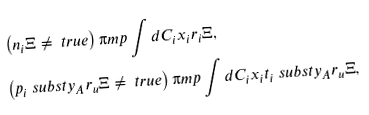Convert formula to latex. <formula><loc_0><loc_0><loc_500><loc_500>& \left ( n _ { i } \Xi \neq \ t r u e \right ) \i m p \int d { C _ { i } } { x _ { i } } { r _ { i } \Xi } , \\ & \left ( p _ { i } \ s u b s t { y _ { A } } { r _ { u } \Xi } \neq \ t r u e \right ) \i m p \int d { C _ { i } } { x _ { i } } { t _ { i } \ s u b s t { y _ { A } } { r _ { u } \Xi } } ,</formula> 